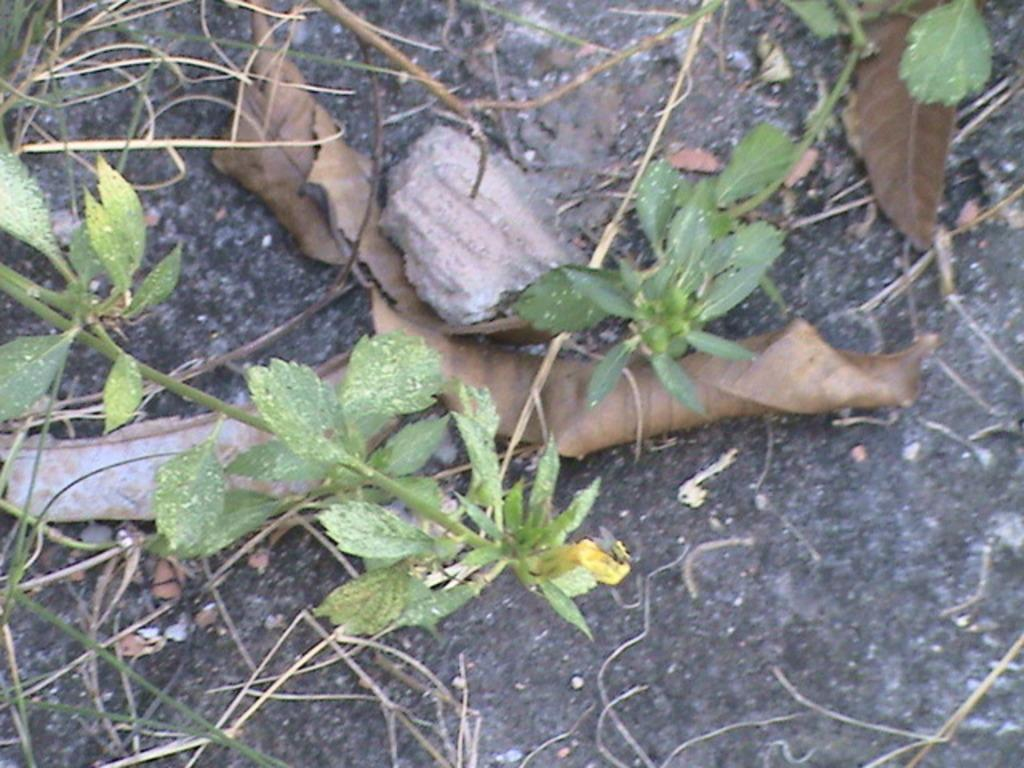What type of plant material is in the center of the image? There are green leaves and stems of plants in the center of the image. What is the condition of the leaves in the image? Dry leaves are present in the image. What can be observed about the arrangement of objects in the image? There are other objects lying on the surface of an object in the image. What type of glass is being used to make a wish in the image? There is no glass or wish-making activity present in the image. 